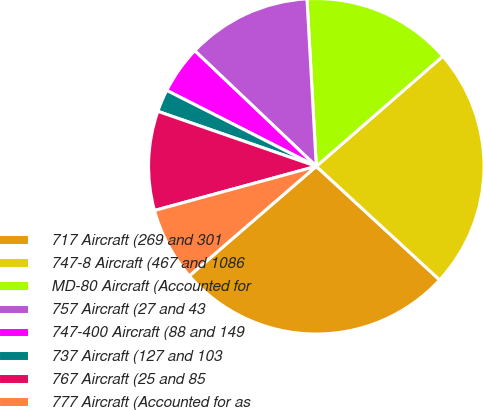Convert chart. <chart><loc_0><loc_0><loc_500><loc_500><pie_chart><fcel>717 Aircraft (269 and 301<fcel>747-8 Aircraft (467 and 1086<fcel>MD-80 Aircraft (Accounted for<fcel>757 Aircraft (27 and 43<fcel>747-400 Aircraft (88 and 149<fcel>737 Aircraft (127 and 103<fcel>767 Aircraft (25 and 85<fcel>777 Aircraft (Accounted for as<nl><fcel>26.82%<fcel>23.25%<fcel>14.49%<fcel>12.02%<fcel>4.62%<fcel>2.16%<fcel>9.56%<fcel>7.09%<nl></chart> 